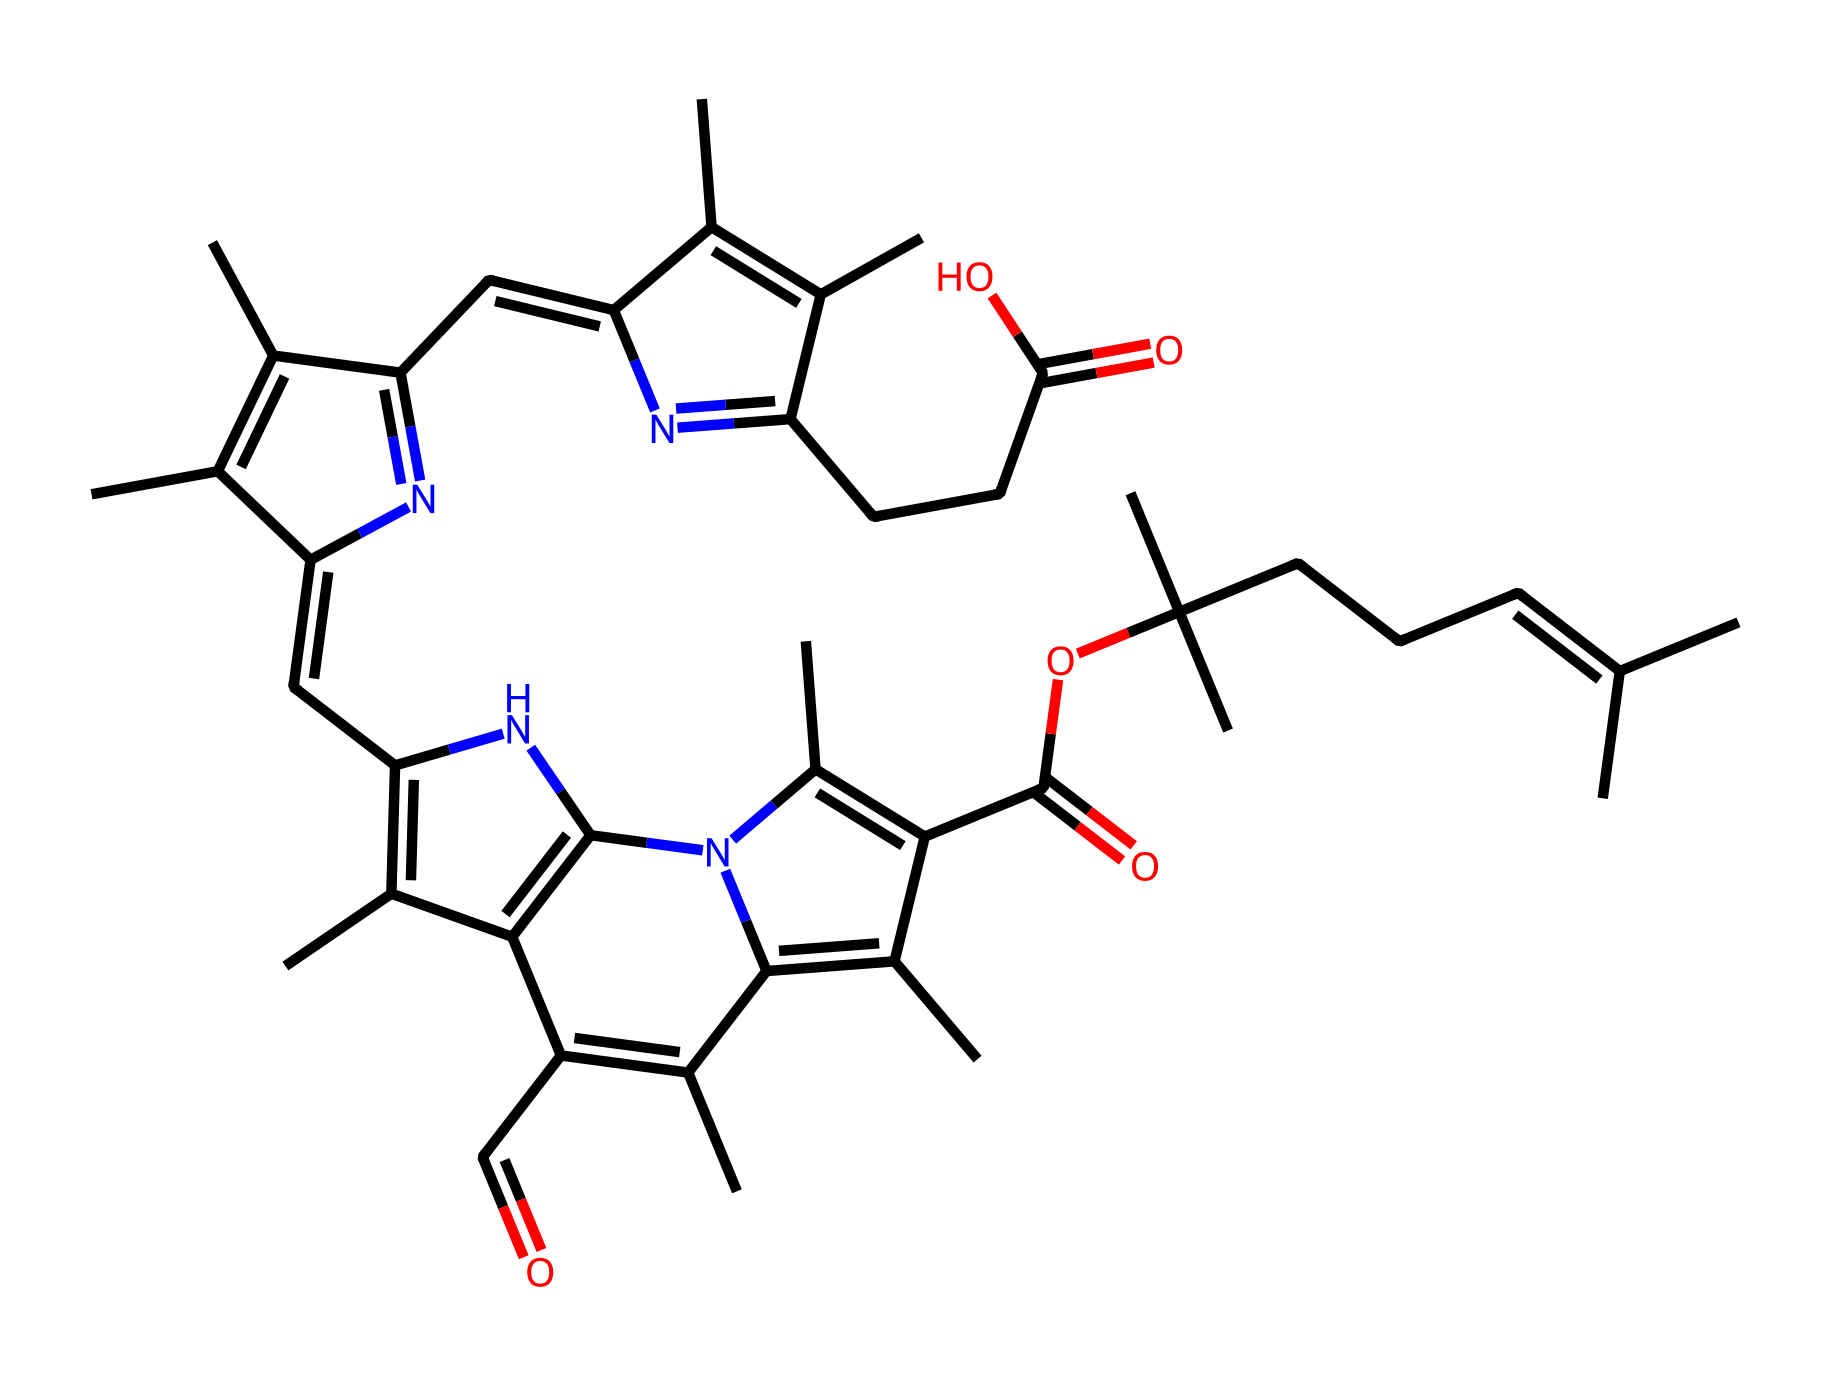What is the molecular formula of this chemical? To find the molecular formula, count the number of carbon (C), hydrogen (H), nitrogen (N), and oxygen (O) atoms represented in the structure. Based on the structure, the molecular formula is C33H48N8O6.
Answer: C33H48N8O6 How many nitrogen atoms are present in this molecule? By inspecting the structure, we can identify each nitrogen atom present. There are a total of 8 nitrogen atoms visible in the structure.
Answer: 8 What functional groups are present in this chemical? Look for characteristic groups in the structure such as carbonyl (C=O) and ester (C(=O)O). In this structure, both an ester and carbonyl groups are identifiable.
Answer: ester, carbonyl Does this chemical contain any double bonds? Examine the lines in the structure; double bonds are represented by two lines between atoms. Counting these, it is clear that there are multiple double bonds present in the structure.
Answer: yes What role does this molecule play in photosynthesis? This compound, due to its chlorophyll-like structure, plays a crucial role in absorbing light energy to convert it into chemical energy during photosynthesis.
Answer: light absorption How does the arrangement of atoms in this chemical affect its function? The specific arrangement of atoms, including the placement of nitrogen and the cyclic structures, is crucial for allowing the molecule to effectively absorb photons, which initiates the process of photosynthesis.
Answer: enhances light absorption What type of molecule is represented here? By analyzing the components of the chemical, particularly the presence of chlorin rings and nitrogen, this molecule is classified as a porphyrin derivative, specifically chlorophyll.
Answer: chlorophyll 